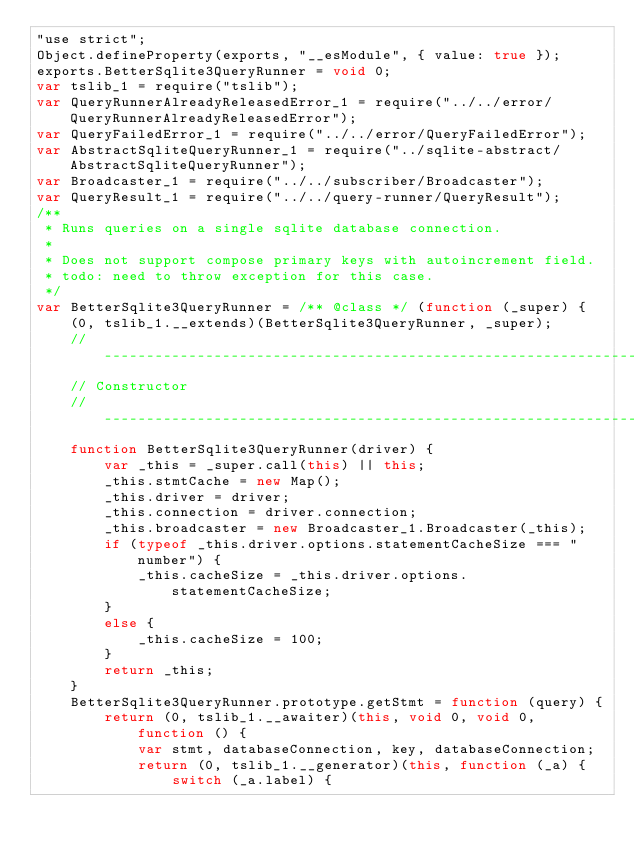Convert code to text. <code><loc_0><loc_0><loc_500><loc_500><_JavaScript_>"use strict";
Object.defineProperty(exports, "__esModule", { value: true });
exports.BetterSqlite3QueryRunner = void 0;
var tslib_1 = require("tslib");
var QueryRunnerAlreadyReleasedError_1 = require("../../error/QueryRunnerAlreadyReleasedError");
var QueryFailedError_1 = require("../../error/QueryFailedError");
var AbstractSqliteQueryRunner_1 = require("../sqlite-abstract/AbstractSqliteQueryRunner");
var Broadcaster_1 = require("../../subscriber/Broadcaster");
var QueryResult_1 = require("../../query-runner/QueryResult");
/**
 * Runs queries on a single sqlite database connection.
 *
 * Does not support compose primary keys with autoincrement field.
 * todo: need to throw exception for this case.
 */
var BetterSqlite3QueryRunner = /** @class */ (function (_super) {
    (0, tslib_1.__extends)(BetterSqlite3QueryRunner, _super);
    // -------------------------------------------------------------------------
    // Constructor
    // -------------------------------------------------------------------------
    function BetterSqlite3QueryRunner(driver) {
        var _this = _super.call(this) || this;
        _this.stmtCache = new Map();
        _this.driver = driver;
        _this.connection = driver.connection;
        _this.broadcaster = new Broadcaster_1.Broadcaster(_this);
        if (typeof _this.driver.options.statementCacheSize === "number") {
            _this.cacheSize = _this.driver.options.statementCacheSize;
        }
        else {
            _this.cacheSize = 100;
        }
        return _this;
    }
    BetterSqlite3QueryRunner.prototype.getStmt = function (query) {
        return (0, tslib_1.__awaiter)(this, void 0, void 0, function () {
            var stmt, databaseConnection, key, databaseConnection;
            return (0, tslib_1.__generator)(this, function (_a) {
                switch (_a.label) {</code> 